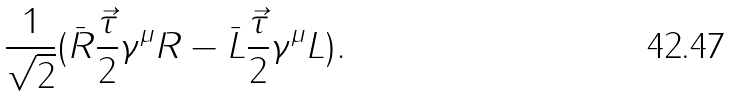Convert formula to latex. <formula><loc_0><loc_0><loc_500><loc_500>\frac { 1 } { \sqrt { 2 } } ( \bar { R } \frac { \vec { \tau } } { 2 } \gamma ^ { \mu } R - \bar { L } \frac { \vec { \tau } } { 2 } \gamma ^ { \mu } L ) .</formula> 